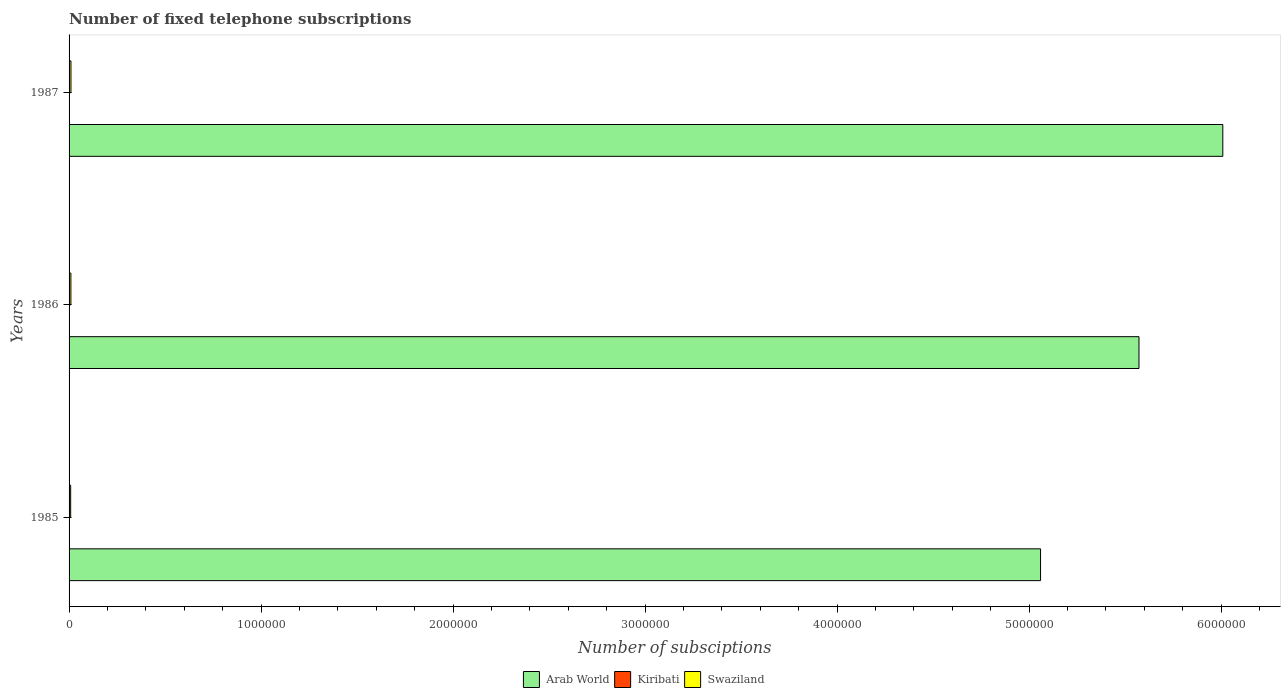How many groups of bars are there?
Keep it short and to the point. 3. Are the number of bars on each tick of the Y-axis equal?
Offer a terse response. Yes. How many bars are there on the 1st tick from the bottom?
Keep it short and to the point. 3. What is the label of the 2nd group of bars from the top?
Give a very brief answer. 1986. What is the number of fixed telephone subscriptions in Swaziland in 1986?
Your answer should be compact. 9440. Across all years, what is the maximum number of fixed telephone subscriptions in Kiribati?
Provide a short and direct response. 910. Across all years, what is the minimum number of fixed telephone subscriptions in Swaziland?
Your answer should be very brief. 8300. In which year was the number of fixed telephone subscriptions in Arab World maximum?
Give a very brief answer. 1987. In which year was the number of fixed telephone subscriptions in Kiribati minimum?
Keep it short and to the point. 1985. What is the total number of fixed telephone subscriptions in Swaziland in the graph?
Give a very brief answer. 2.76e+04. What is the difference between the number of fixed telephone subscriptions in Kiribati in 1985 and that in 1987?
Offer a very short reply. -241. What is the difference between the number of fixed telephone subscriptions in Kiribati in 1985 and the number of fixed telephone subscriptions in Swaziland in 1986?
Provide a succinct answer. -8771. What is the average number of fixed telephone subscriptions in Arab World per year?
Offer a terse response. 5.55e+06. In the year 1987, what is the difference between the number of fixed telephone subscriptions in Kiribati and number of fixed telephone subscriptions in Arab World?
Provide a short and direct response. -6.01e+06. What is the ratio of the number of fixed telephone subscriptions in Swaziland in 1985 to that in 1986?
Offer a very short reply. 0.88. What is the difference between the highest and the second highest number of fixed telephone subscriptions in Swaziland?
Your response must be concise. 376. What is the difference between the highest and the lowest number of fixed telephone subscriptions in Arab World?
Provide a succinct answer. 9.49e+05. In how many years, is the number of fixed telephone subscriptions in Swaziland greater than the average number of fixed telephone subscriptions in Swaziland taken over all years?
Give a very brief answer. 2. What does the 2nd bar from the top in 1985 represents?
Offer a very short reply. Kiribati. What does the 2nd bar from the bottom in 1986 represents?
Ensure brevity in your answer.  Kiribati. Is it the case that in every year, the sum of the number of fixed telephone subscriptions in Kiribati and number of fixed telephone subscriptions in Swaziland is greater than the number of fixed telephone subscriptions in Arab World?
Provide a short and direct response. No. How many years are there in the graph?
Give a very brief answer. 3. What is the difference between two consecutive major ticks on the X-axis?
Your answer should be very brief. 1.00e+06. Does the graph contain any zero values?
Keep it short and to the point. No. Does the graph contain grids?
Offer a very short reply. No. How many legend labels are there?
Give a very brief answer. 3. What is the title of the graph?
Make the answer very short. Number of fixed telephone subscriptions. What is the label or title of the X-axis?
Make the answer very short. Number of subsciptions. What is the label or title of the Y-axis?
Offer a terse response. Years. What is the Number of subsciptions of Arab World in 1985?
Offer a terse response. 5.06e+06. What is the Number of subsciptions in Kiribati in 1985?
Your response must be concise. 669. What is the Number of subsciptions in Swaziland in 1985?
Your answer should be compact. 8300. What is the Number of subsciptions in Arab World in 1986?
Provide a succinct answer. 5.57e+06. What is the Number of subsciptions of Kiribati in 1986?
Ensure brevity in your answer.  800. What is the Number of subsciptions in Swaziland in 1986?
Your answer should be very brief. 9440. What is the Number of subsciptions in Arab World in 1987?
Make the answer very short. 6.01e+06. What is the Number of subsciptions of Kiribati in 1987?
Provide a short and direct response. 910. What is the Number of subsciptions in Swaziland in 1987?
Give a very brief answer. 9816. Across all years, what is the maximum Number of subsciptions of Arab World?
Offer a terse response. 6.01e+06. Across all years, what is the maximum Number of subsciptions of Kiribati?
Provide a short and direct response. 910. Across all years, what is the maximum Number of subsciptions of Swaziland?
Offer a very short reply. 9816. Across all years, what is the minimum Number of subsciptions of Arab World?
Offer a terse response. 5.06e+06. Across all years, what is the minimum Number of subsciptions in Kiribati?
Your answer should be very brief. 669. Across all years, what is the minimum Number of subsciptions in Swaziland?
Your response must be concise. 8300. What is the total Number of subsciptions of Arab World in the graph?
Ensure brevity in your answer.  1.66e+07. What is the total Number of subsciptions in Kiribati in the graph?
Offer a terse response. 2379. What is the total Number of subsciptions in Swaziland in the graph?
Your answer should be compact. 2.76e+04. What is the difference between the Number of subsciptions of Arab World in 1985 and that in 1986?
Ensure brevity in your answer.  -5.13e+05. What is the difference between the Number of subsciptions in Kiribati in 1985 and that in 1986?
Make the answer very short. -131. What is the difference between the Number of subsciptions in Swaziland in 1985 and that in 1986?
Make the answer very short. -1140. What is the difference between the Number of subsciptions of Arab World in 1985 and that in 1987?
Provide a succinct answer. -9.49e+05. What is the difference between the Number of subsciptions in Kiribati in 1985 and that in 1987?
Make the answer very short. -241. What is the difference between the Number of subsciptions of Swaziland in 1985 and that in 1987?
Your answer should be very brief. -1516. What is the difference between the Number of subsciptions of Arab World in 1986 and that in 1987?
Your response must be concise. -4.37e+05. What is the difference between the Number of subsciptions in Kiribati in 1986 and that in 1987?
Give a very brief answer. -110. What is the difference between the Number of subsciptions of Swaziland in 1986 and that in 1987?
Keep it short and to the point. -376. What is the difference between the Number of subsciptions of Arab World in 1985 and the Number of subsciptions of Kiribati in 1986?
Offer a very short reply. 5.06e+06. What is the difference between the Number of subsciptions of Arab World in 1985 and the Number of subsciptions of Swaziland in 1986?
Your response must be concise. 5.05e+06. What is the difference between the Number of subsciptions in Kiribati in 1985 and the Number of subsciptions in Swaziland in 1986?
Offer a terse response. -8771. What is the difference between the Number of subsciptions of Arab World in 1985 and the Number of subsciptions of Kiribati in 1987?
Make the answer very short. 5.06e+06. What is the difference between the Number of subsciptions in Arab World in 1985 and the Number of subsciptions in Swaziland in 1987?
Keep it short and to the point. 5.05e+06. What is the difference between the Number of subsciptions in Kiribati in 1985 and the Number of subsciptions in Swaziland in 1987?
Your response must be concise. -9147. What is the difference between the Number of subsciptions of Arab World in 1986 and the Number of subsciptions of Kiribati in 1987?
Your answer should be compact. 5.57e+06. What is the difference between the Number of subsciptions of Arab World in 1986 and the Number of subsciptions of Swaziland in 1987?
Your answer should be compact. 5.56e+06. What is the difference between the Number of subsciptions in Kiribati in 1986 and the Number of subsciptions in Swaziland in 1987?
Provide a short and direct response. -9016. What is the average Number of subsciptions of Arab World per year?
Your answer should be very brief. 5.55e+06. What is the average Number of subsciptions of Kiribati per year?
Provide a short and direct response. 793. What is the average Number of subsciptions of Swaziland per year?
Your answer should be very brief. 9185.33. In the year 1985, what is the difference between the Number of subsciptions of Arab World and Number of subsciptions of Kiribati?
Your answer should be compact. 5.06e+06. In the year 1985, what is the difference between the Number of subsciptions of Arab World and Number of subsciptions of Swaziland?
Make the answer very short. 5.05e+06. In the year 1985, what is the difference between the Number of subsciptions of Kiribati and Number of subsciptions of Swaziland?
Provide a short and direct response. -7631. In the year 1986, what is the difference between the Number of subsciptions in Arab World and Number of subsciptions in Kiribati?
Your response must be concise. 5.57e+06. In the year 1986, what is the difference between the Number of subsciptions of Arab World and Number of subsciptions of Swaziland?
Your answer should be very brief. 5.56e+06. In the year 1986, what is the difference between the Number of subsciptions of Kiribati and Number of subsciptions of Swaziland?
Provide a succinct answer. -8640. In the year 1987, what is the difference between the Number of subsciptions in Arab World and Number of subsciptions in Kiribati?
Your answer should be very brief. 6.01e+06. In the year 1987, what is the difference between the Number of subsciptions of Arab World and Number of subsciptions of Swaziland?
Provide a succinct answer. 6.00e+06. In the year 1987, what is the difference between the Number of subsciptions of Kiribati and Number of subsciptions of Swaziland?
Offer a terse response. -8906. What is the ratio of the Number of subsciptions in Arab World in 1985 to that in 1986?
Keep it short and to the point. 0.91. What is the ratio of the Number of subsciptions in Kiribati in 1985 to that in 1986?
Your response must be concise. 0.84. What is the ratio of the Number of subsciptions of Swaziland in 1985 to that in 1986?
Make the answer very short. 0.88. What is the ratio of the Number of subsciptions of Arab World in 1985 to that in 1987?
Keep it short and to the point. 0.84. What is the ratio of the Number of subsciptions in Kiribati in 1985 to that in 1987?
Your answer should be very brief. 0.74. What is the ratio of the Number of subsciptions in Swaziland in 1985 to that in 1987?
Your answer should be very brief. 0.85. What is the ratio of the Number of subsciptions in Arab World in 1986 to that in 1987?
Keep it short and to the point. 0.93. What is the ratio of the Number of subsciptions of Kiribati in 1986 to that in 1987?
Offer a very short reply. 0.88. What is the ratio of the Number of subsciptions in Swaziland in 1986 to that in 1987?
Your answer should be very brief. 0.96. What is the difference between the highest and the second highest Number of subsciptions of Arab World?
Ensure brevity in your answer.  4.37e+05. What is the difference between the highest and the second highest Number of subsciptions of Kiribati?
Your response must be concise. 110. What is the difference between the highest and the second highest Number of subsciptions of Swaziland?
Keep it short and to the point. 376. What is the difference between the highest and the lowest Number of subsciptions of Arab World?
Offer a terse response. 9.49e+05. What is the difference between the highest and the lowest Number of subsciptions in Kiribati?
Keep it short and to the point. 241. What is the difference between the highest and the lowest Number of subsciptions in Swaziland?
Offer a very short reply. 1516. 